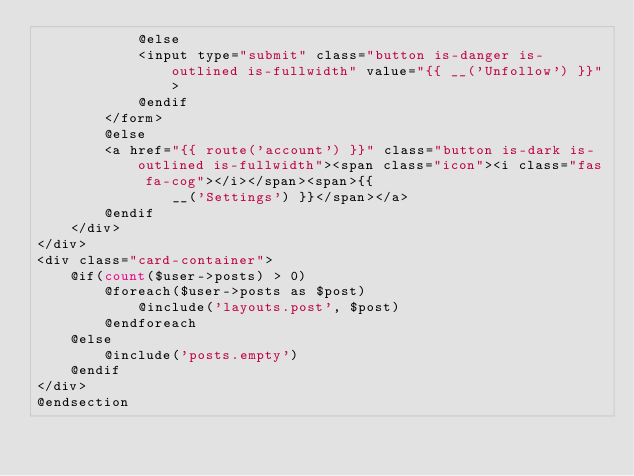<code> <loc_0><loc_0><loc_500><loc_500><_PHP_>            @else
            <input type="submit" class="button is-danger is-outlined is-fullwidth" value="{{ __('Unfollow') }}">
            @endif
        </form>
        @else
        <a href="{{ route('account') }}" class="button is-dark is-outlined is-fullwidth"><span class="icon"><i class="fas fa-cog"></i></span><span>{{
                __('Settings') }}</span></a>
        @endif
    </div>
</div>
<div class="card-container">
    @if(count($user->posts) > 0)
        @foreach($user->posts as $post)
            @include('layouts.post', $post)
        @endforeach
    @else
        @include('posts.empty')
    @endif
</div>
@endsection
</code> 